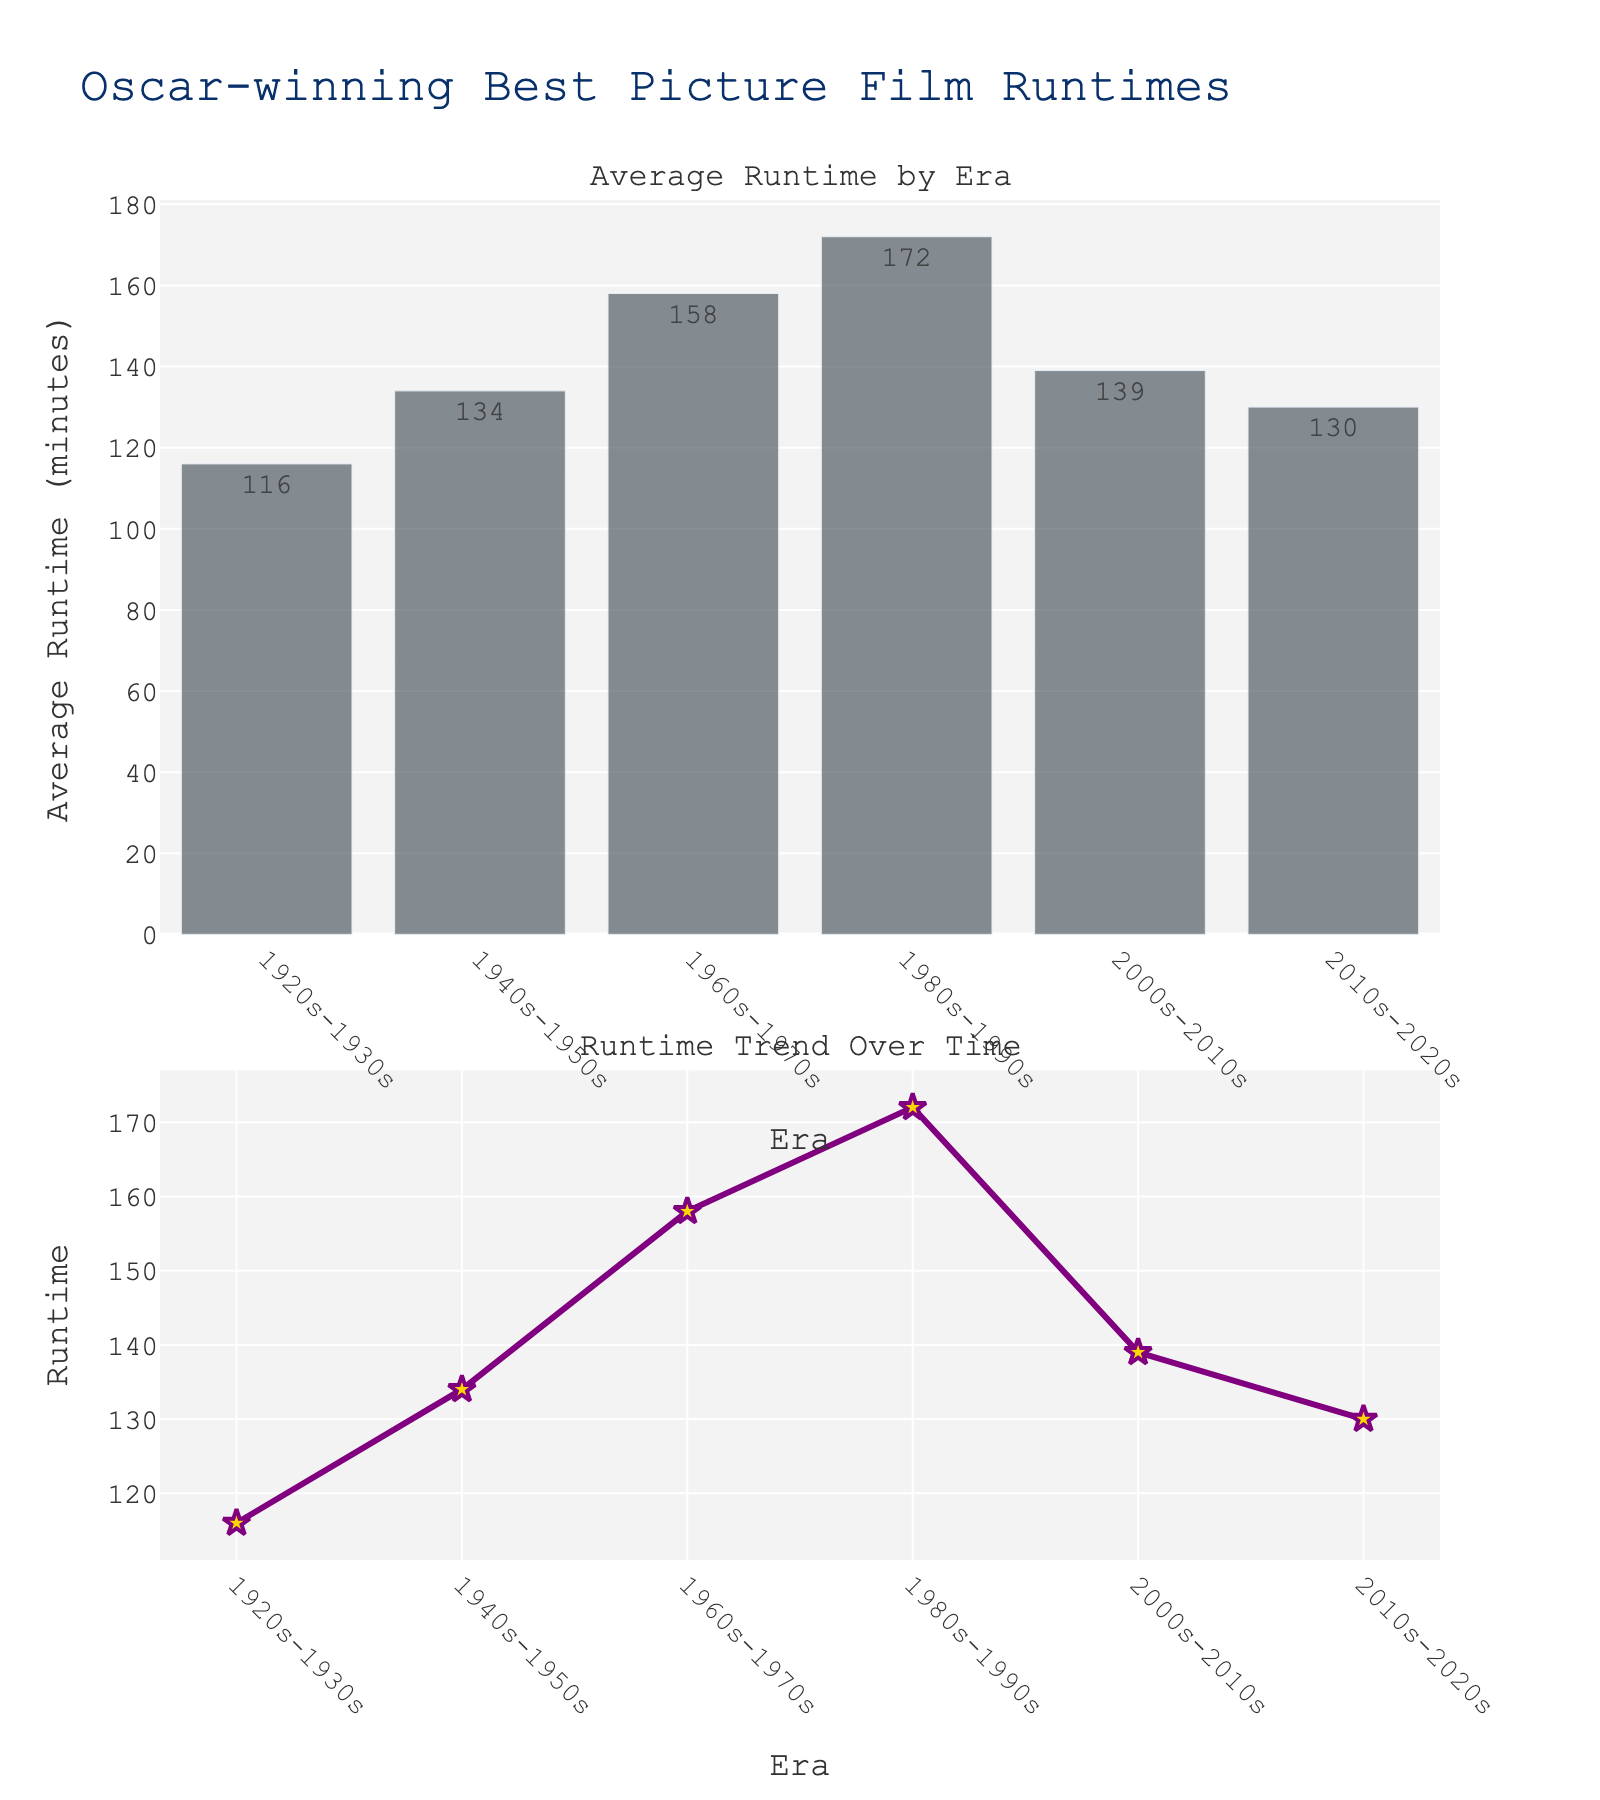What's the title of the plot? The title is displayed at the top of the figure, making it the first visual element to read.
Answer: "Oscar-winning Best Picture Film Runtimes" How many eras are compared in the plot? Count the number of distinct x-axis labels, as each represents an era. There are 6 labels seen in both plots.
Answer: 6 Which era has the longest average runtime for Oscar-winning Best Picture films according to the bar plot? Refer to the highest bar in the first subplot. The highest bar corresponds to the 1980s-1990s era.
Answer: 1980s-1990s What is the average runtime for the 2000s-2010s era? Look for the bar labeled "2000s-2010s" and read the value displayed at the top of the bar.
Answer: 139 minutes Which era shows a decrease in average runtime compared to the previous era according to the second plot? View the line plot and look for points where the line descends. The descent occurs from the 1980s-1990s to the 2000s-2010s era.
Answer: 2000s-2010s How much does the average runtime increase from the 1940s-1950s to the 1980s-1990s? Subtract the 1940s-1950s bar value from the 1980s-1990s bar value: 172 - 134 = 38.
Answer: 38 minutes Between which two consecutive eras did the average runtime decrease the most according to the line plot? Measure the drop between adjacent points and compare: the largest drop is from 1980s-1990s (172) to 2000s-2010s (139).
Answer: 1980s-1990s and 2000s-2010s Which eras have average runtimes over 150 minutes? Identify any bars or points above the 150-minute line, which are 1960s-1970s and 1980s-1990s.
Answer: 1960s-1970s, 1980s-1990s What trend in runtime lengths can be observed over the entire period depicted? Follow the line in the second plot: it shows an increase in runtime from the 1920s-1930s period to the 1980s-1990s, followed by a decline in the 2000s-2020s.
Answer: Increase, then decrease How is the runtime data visually distinguished in the line plot? The runtime data points are marked with gold stars and connected by a purple line. This distinctive visual encoding helps separate it from other elements.
Answer: Gold stars connected by a purple line 